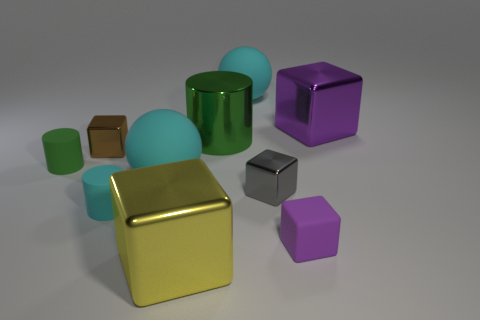Subtract all big cylinders. How many cylinders are left? 2 Subtract all gray cubes. How many green cylinders are left? 2 Subtract all cyan cylinders. How many cylinders are left? 2 Subtract all cylinders. How many objects are left? 7 Subtract all purple blocks. Subtract all brown cylinders. How many blocks are left? 3 Add 2 small gray metallic blocks. How many small gray metallic blocks exist? 3 Subtract 0 brown spheres. How many objects are left? 10 Subtract all purple matte spheres. Subtract all matte blocks. How many objects are left? 9 Add 5 cyan cylinders. How many cyan cylinders are left? 6 